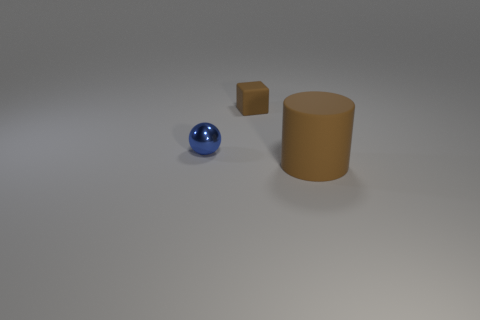Add 2 rubber blocks. How many objects exist? 5 Subtract all cylinders. How many objects are left? 2 Subtract all tiny brown metal cylinders. Subtract all brown rubber things. How many objects are left? 1 Add 1 tiny balls. How many tiny balls are left? 2 Add 1 small brown objects. How many small brown objects exist? 2 Subtract 0 purple cylinders. How many objects are left? 3 